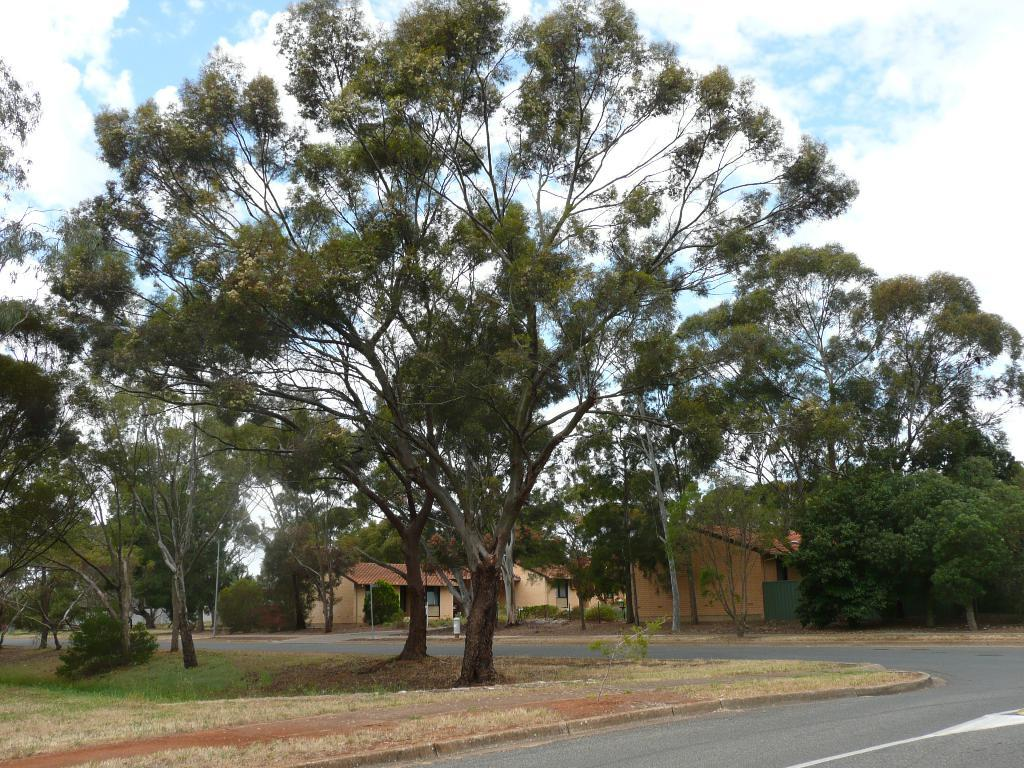What type of surface can be seen in the image? There is a road in the image. What type of vegetation is present in the image? There are trees, plants, and grass in the image. What structures can be seen in the image? There are poles and houses in the image. What is visible in the background of the image? The sky is visible behind the trees, and it appears to be cloudy. How many divisions are visible in the image? There is no mention of divisions in the image; it features a road, trees, plants, grass, poles, houses, and a cloudy sky. Can you describe the view from the top of the tallest tree in the image? There is no view from the top of the trees in the image, as it is a still photograph and not a live video. 